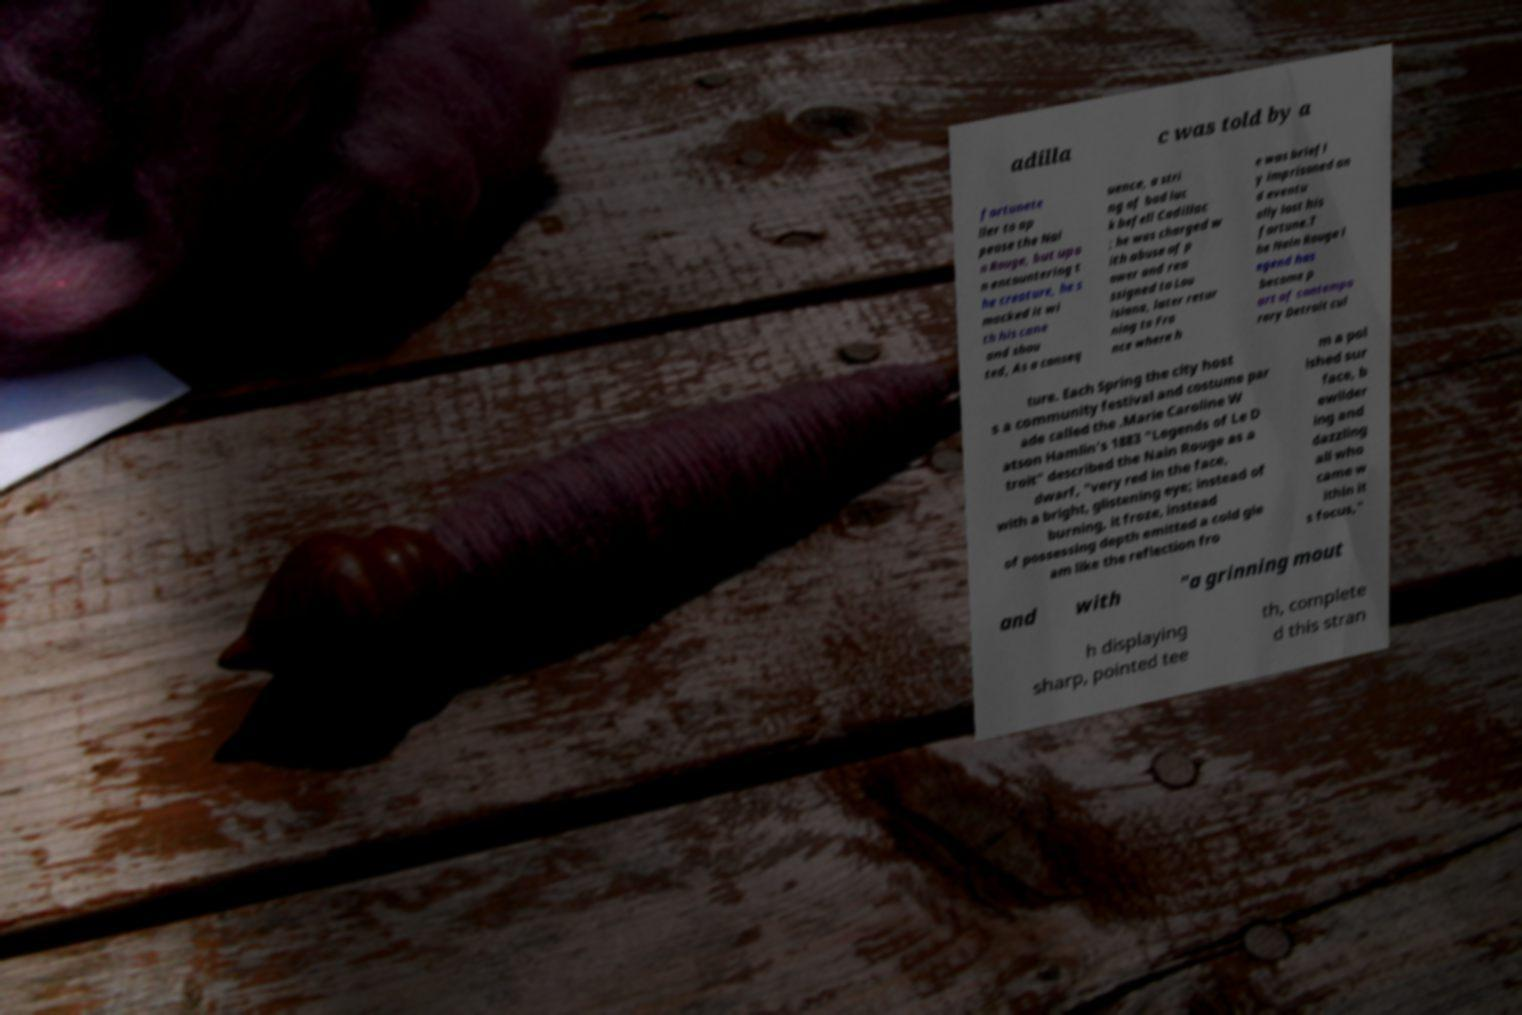For documentation purposes, I need the text within this image transcribed. Could you provide that? adilla c was told by a fortunete ller to ap pease the Nai n Rouge, but upo n encountering t he creature, he s macked it wi th his cane and shou ted, As a conseq uence, a stri ng of bad luc k befell Cadillac ; he was charged w ith abuse of p ower and rea ssigned to Lou isiana, later retur ning to Fra nce where h e was briefl y imprisoned an d eventu ally lost his fortune.T he Nain Rouge l egend has become p art of contempo rary Detroit cul ture. Each Spring the city host s a community festival and costume par ade called the .Marie Caroline W atson Hamlin's 1883 "Legends of Le D troit" described the Nain Rouge as a dwarf, "very red in the face, with a bright, glistening eye; instead of burning, it froze, instead of possessing depth emitted a cold gle am like the reflection fro m a pol ished sur face, b ewilder ing and dazzling all who came w ithin it s focus," and with "a grinning mout h displaying sharp, pointed tee th, complete d this stran 